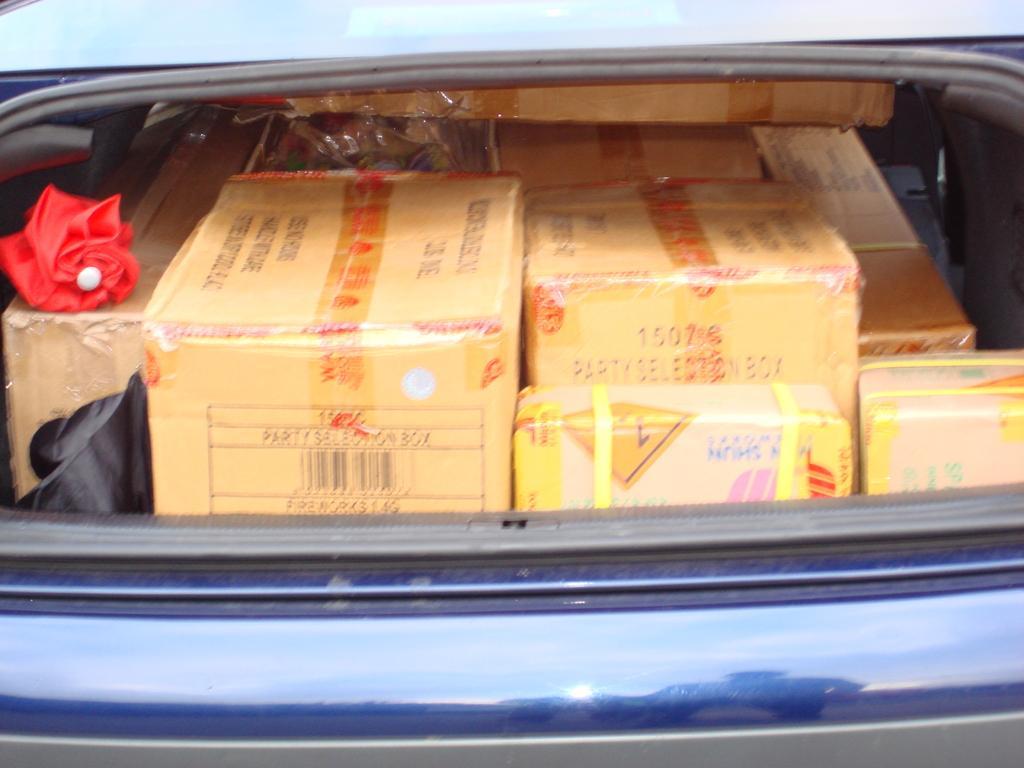In one or two sentences, can you explain what this image depicts? In the image we can see a vehicle, in the vehicle there are some boxes and there is an umbrella. 